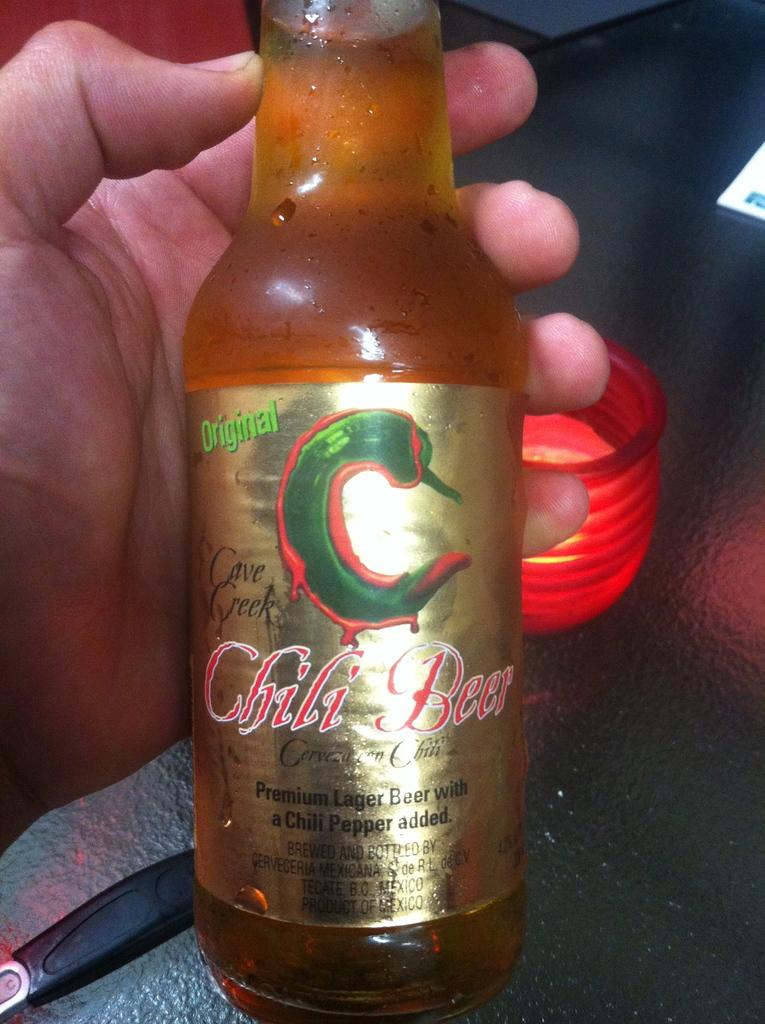What brand beer is this?
Ensure brevity in your answer.  Cave creek. 